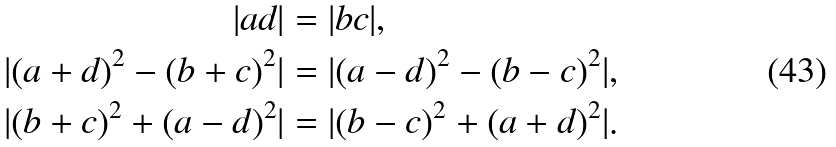<formula> <loc_0><loc_0><loc_500><loc_500>| a d | & = | b c | , \\ | ( a + d ) ^ { 2 } - ( b + c ) ^ { 2 } | & = | ( a - d ) ^ { 2 } - ( b - c ) ^ { 2 } | , \\ | ( b + c ) ^ { 2 } + ( a - d ) ^ { 2 } | & = | ( b - c ) ^ { 2 } + ( a + d ) ^ { 2 } | .</formula> 